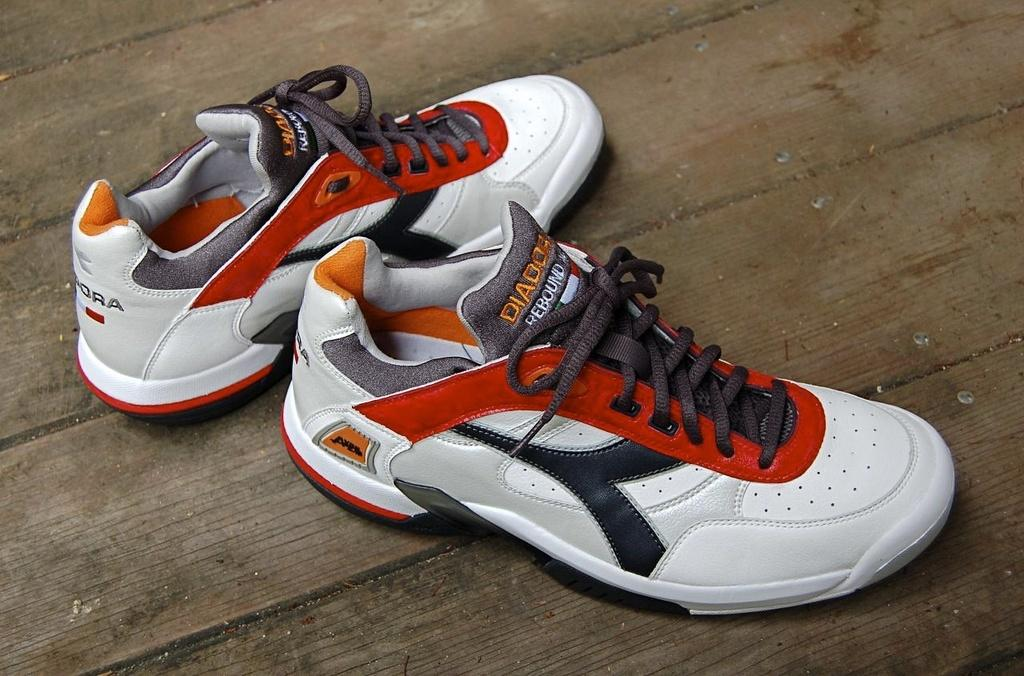What type of footwear is present in the image? There is a pair of shoes in the image. Where are the shoes located? The pair of shoes is on a platform. What type of silk material is used to make the shoes in the image? There is no mention of silk or any specific material used to make the shoes in the image. Can you see the ocean in the background of the image? There is no reference to an ocean or any body of water in the image. 